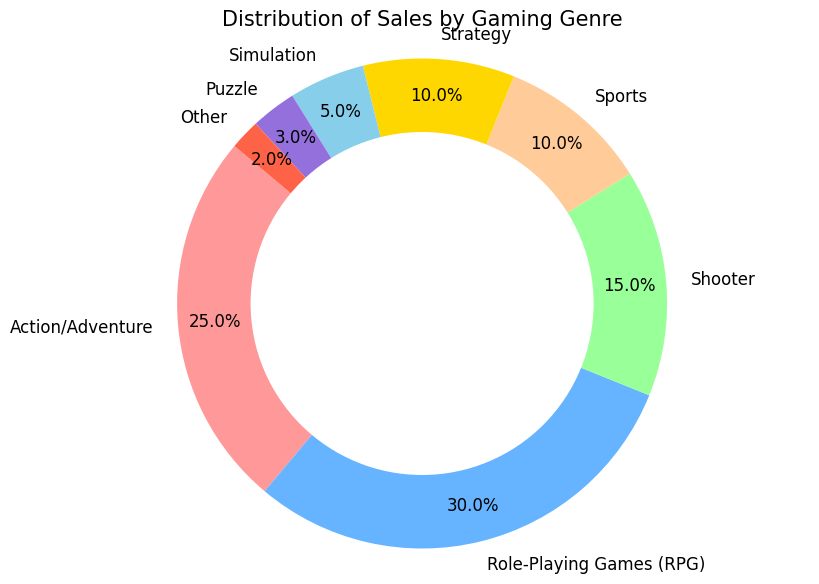Which gaming genre has the largest share of sales in your store? By observing the pie chart, the largest slice corresponds to Role-Playing Games (RPG) with a 30% share.
Answer: Role-Playing Games (RPG) What is the combined sales percentage of Shooter and Sports genres? Shooter has a 15% share and Sports has a 10% share. Adding them together gives 15% + 10% = 25%.
Answer: 25% Which genre has a smaller sales percentage, Simulation or Puzzle? The pie chart shows the Simulation genre slice as 5% and the Puzzle genre slice as 3%. Since 5% is greater than 3%, Puzzle has a smaller sales percentage.
Answer: Puzzle How many genres have a sales percentage greater than 10%? The genres with sales percentages greater than 10% are Action/Adventure (25%), Role-Playing Games (RPG) (30%), and Shooter (15%). So, there are 3 genres.
Answer: 3 What is the difference in sales percentage between the Action/Adventure and Strategy genres? The Action/Adventure genre has a 25% share while the Strategy genre has a 10%. The difference is 25% - 10% = 15%.
Answer: 15% Which genre has the smallest share of sales, and what is that percentage? By observing the pie chart, the smallest slice corresponds to the Other genre which has a 2% share.
Answer: Other, 2% If the total sales were 10,000 units, how many units were sold in the Simulation genre? Simulation has a 5% share of the sales. 5% of 10,000 units is (5 / 100) * 10,000 = 500 units.
Answer: 500 units Are there more genres with a sales percentage equal to or less than 5% or genres with a sales percentage greater than 5%? The genres with sales percentages equal to or less than 5% are Simulation (5%), Puzzle (3%), and Other (2%)—a total of 3 genres. The genres with sales percentages greater than 5% are Action/Adventure (25%), Role-Playing Games (RPG) (30%), Shooter (15%), and Sports (10%)—a total of 4 genres. 4 is more than 3.
Answer: Genres greater than 5% 